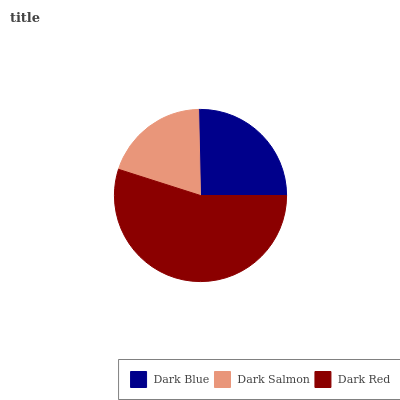Is Dark Salmon the minimum?
Answer yes or no. Yes. Is Dark Red the maximum?
Answer yes or no. Yes. Is Dark Red the minimum?
Answer yes or no. No. Is Dark Salmon the maximum?
Answer yes or no. No. Is Dark Red greater than Dark Salmon?
Answer yes or no. Yes. Is Dark Salmon less than Dark Red?
Answer yes or no. Yes. Is Dark Salmon greater than Dark Red?
Answer yes or no. No. Is Dark Red less than Dark Salmon?
Answer yes or no. No. Is Dark Blue the high median?
Answer yes or no. Yes. Is Dark Blue the low median?
Answer yes or no. Yes. Is Dark Red the high median?
Answer yes or no. No. Is Dark Salmon the low median?
Answer yes or no. No. 